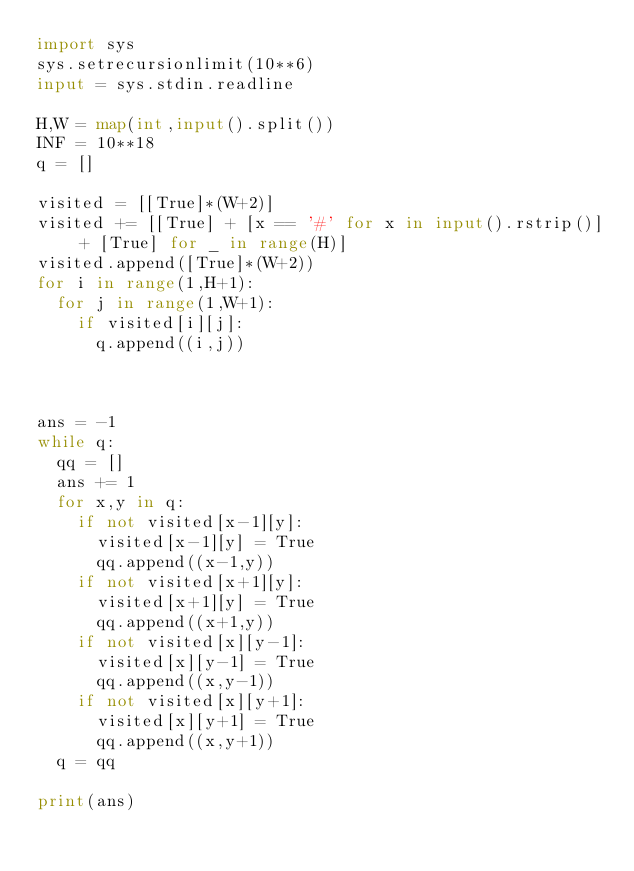Convert code to text. <code><loc_0><loc_0><loc_500><loc_500><_Python_>import sys
sys.setrecursionlimit(10**6)
input = sys.stdin.readline

H,W = map(int,input().split())
INF = 10**18
q = []

visited = [[True]*(W+2)]
visited += [[True] + [x == '#' for x in input().rstrip()] + [True] for _ in range(H)]
visited.append([True]*(W+2))
for i in range(1,H+1):
  for j in range(1,W+1):
    if visited[i][j]:
      q.append((i,j))



ans = -1
while q:
  qq = []
  ans += 1
  for x,y in q:
    if not visited[x-1][y]:
      visited[x-1][y] = True
      qq.append((x-1,y))
    if not visited[x+1][y]:
      visited[x+1][y] = True
      qq.append((x+1,y))
    if not visited[x][y-1]:
      visited[x][y-1] = True
      qq.append((x,y-1))
    if not visited[x][y+1]:
      visited[x][y+1] = True
      qq.append((x,y+1))
  q = qq
  
print(ans)</code> 